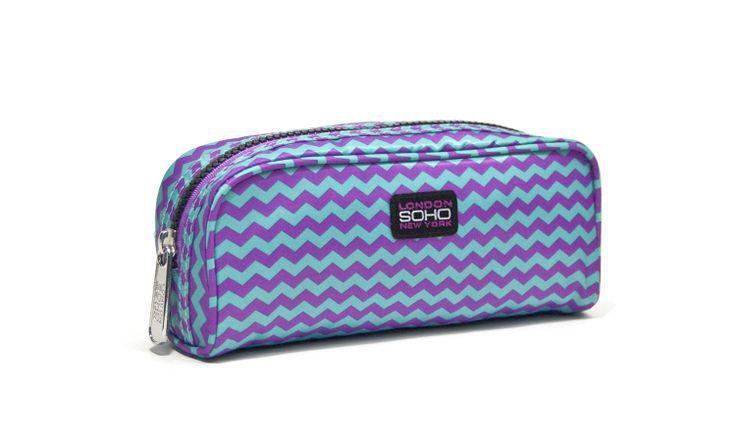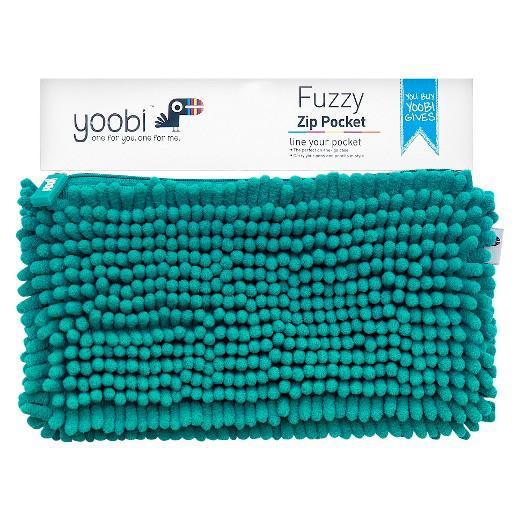The first image is the image on the left, the second image is the image on the right. Given the left and right images, does the statement "One of the images shows a blue bag with white polka dots." hold true? Answer yes or no. No. 